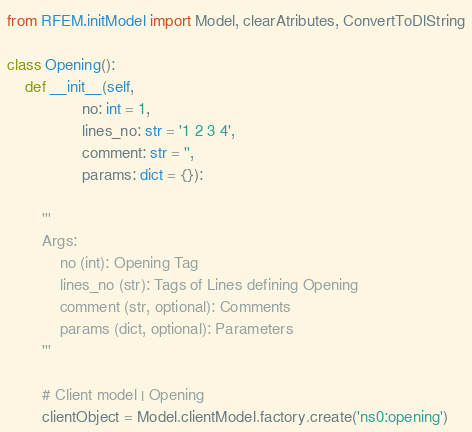Convert code to text. <code><loc_0><loc_0><loc_500><loc_500><_Python_>from RFEM.initModel import Model, clearAtributes, ConvertToDlString

class Opening():
    def __init__(self,
                 no: int = 1,
                 lines_no: str = '1 2 3 4',
                 comment: str = '',
                 params: dict = {}):

        '''
        Args:
            no (int): Opening Tag
            lines_no (str): Tags of Lines defining Opening
            comment (str, optional): Comments
            params (dict, optional): Parameters
        '''

        # Client model | Opening
        clientObject = Model.clientModel.factory.create('ns0:opening')
</code> 